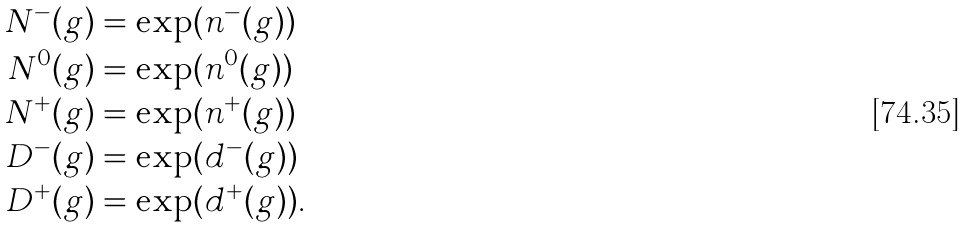Convert formula to latex. <formula><loc_0><loc_0><loc_500><loc_500>N ^ { - } ( g ) & = \exp ( \L n ^ { - } ( g ) ) \\ N ^ { 0 } ( g ) & = \exp ( \L n ^ { 0 } ( g ) ) \\ N ^ { + } ( g ) & = \exp ( \L n ^ { + } ( g ) ) \\ D ^ { - } ( g ) & = \exp ( \L d ^ { - } ( g ) ) \\ D ^ { + } ( g ) & = \exp ( \L d ^ { + } ( g ) ) .</formula> 